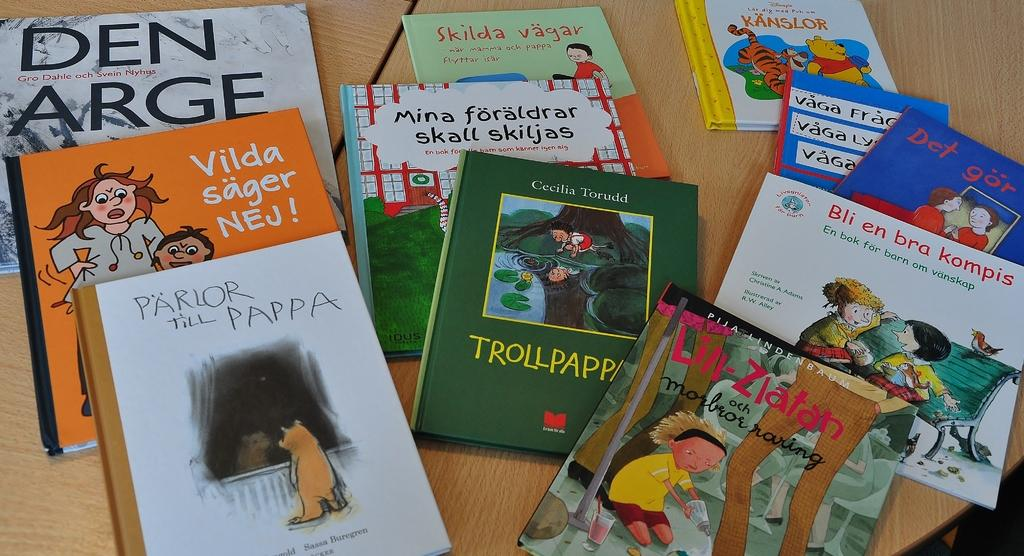<image>
Summarize the visual content of the image. A bunch of children's books on a table, one with a title that reads Bli en bra Kompis. 